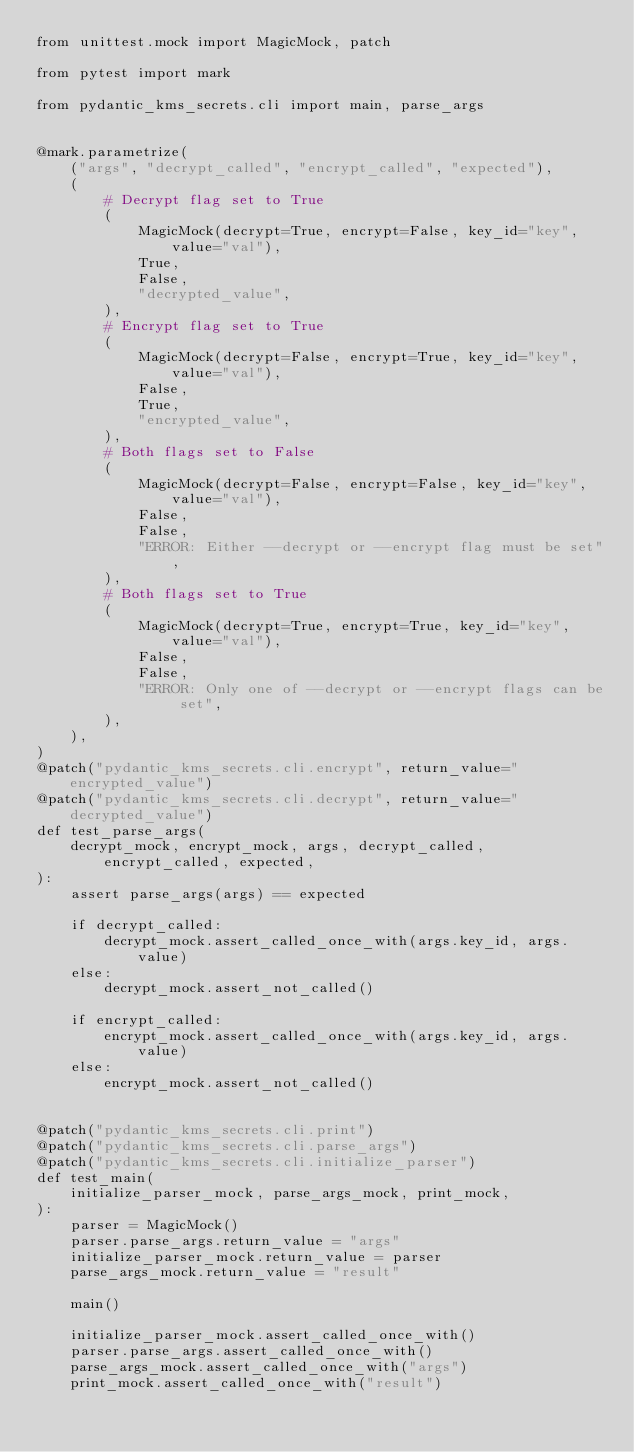Convert code to text. <code><loc_0><loc_0><loc_500><loc_500><_Python_>from unittest.mock import MagicMock, patch

from pytest import mark

from pydantic_kms_secrets.cli import main, parse_args


@mark.parametrize(
    ("args", "decrypt_called", "encrypt_called", "expected"),
    (
        # Decrypt flag set to True
        (
            MagicMock(decrypt=True, encrypt=False, key_id="key", value="val"),
            True,
            False,
            "decrypted_value",
        ),
        # Encrypt flag set to True
        (
            MagicMock(decrypt=False, encrypt=True, key_id="key", value="val"),
            False,
            True,
            "encrypted_value",
        ),
        # Both flags set to False
        (
            MagicMock(decrypt=False, encrypt=False, key_id="key", value="val"),
            False,
            False,
            "ERROR: Either --decrypt or --encrypt flag must be set",
        ),
        # Both flags set to True
        (
            MagicMock(decrypt=True, encrypt=True, key_id="key", value="val"),
            False,
            False,
            "ERROR: Only one of --decrypt or --encrypt flags can be set",
        ),
    ),
)
@patch("pydantic_kms_secrets.cli.encrypt", return_value="encrypted_value")
@patch("pydantic_kms_secrets.cli.decrypt", return_value="decrypted_value")
def test_parse_args(
    decrypt_mock, encrypt_mock, args, decrypt_called, encrypt_called, expected,
):
    assert parse_args(args) == expected

    if decrypt_called:
        decrypt_mock.assert_called_once_with(args.key_id, args.value)
    else:
        decrypt_mock.assert_not_called()

    if encrypt_called:
        encrypt_mock.assert_called_once_with(args.key_id, args.value)
    else:
        encrypt_mock.assert_not_called()


@patch("pydantic_kms_secrets.cli.print")
@patch("pydantic_kms_secrets.cli.parse_args")
@patch("pydantic_kms_secrets.cli.initialize_parser")
def test_main(
    initialize_parser_mock, parse_args_mock, print_mock,
):
    parser = MagicMock()
    parser.parse_args.return_value = "args"
    initialize_parser_mock.return_value = parser
    parse_args_mock.return_value = "result"

    main()

    initialize_parser_mock.assert_called_once_with()
    parser.parse_args.assert_called_once_with()
    parse_args_mock.assert_called_once_with("args")
    print_mock.assert_called_once_with("result")
</code> 